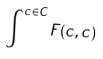<formula> <loc_0><loc_0><loc_500><loc_500>\int ^ { c \in C } F ( c , c )</formula> 